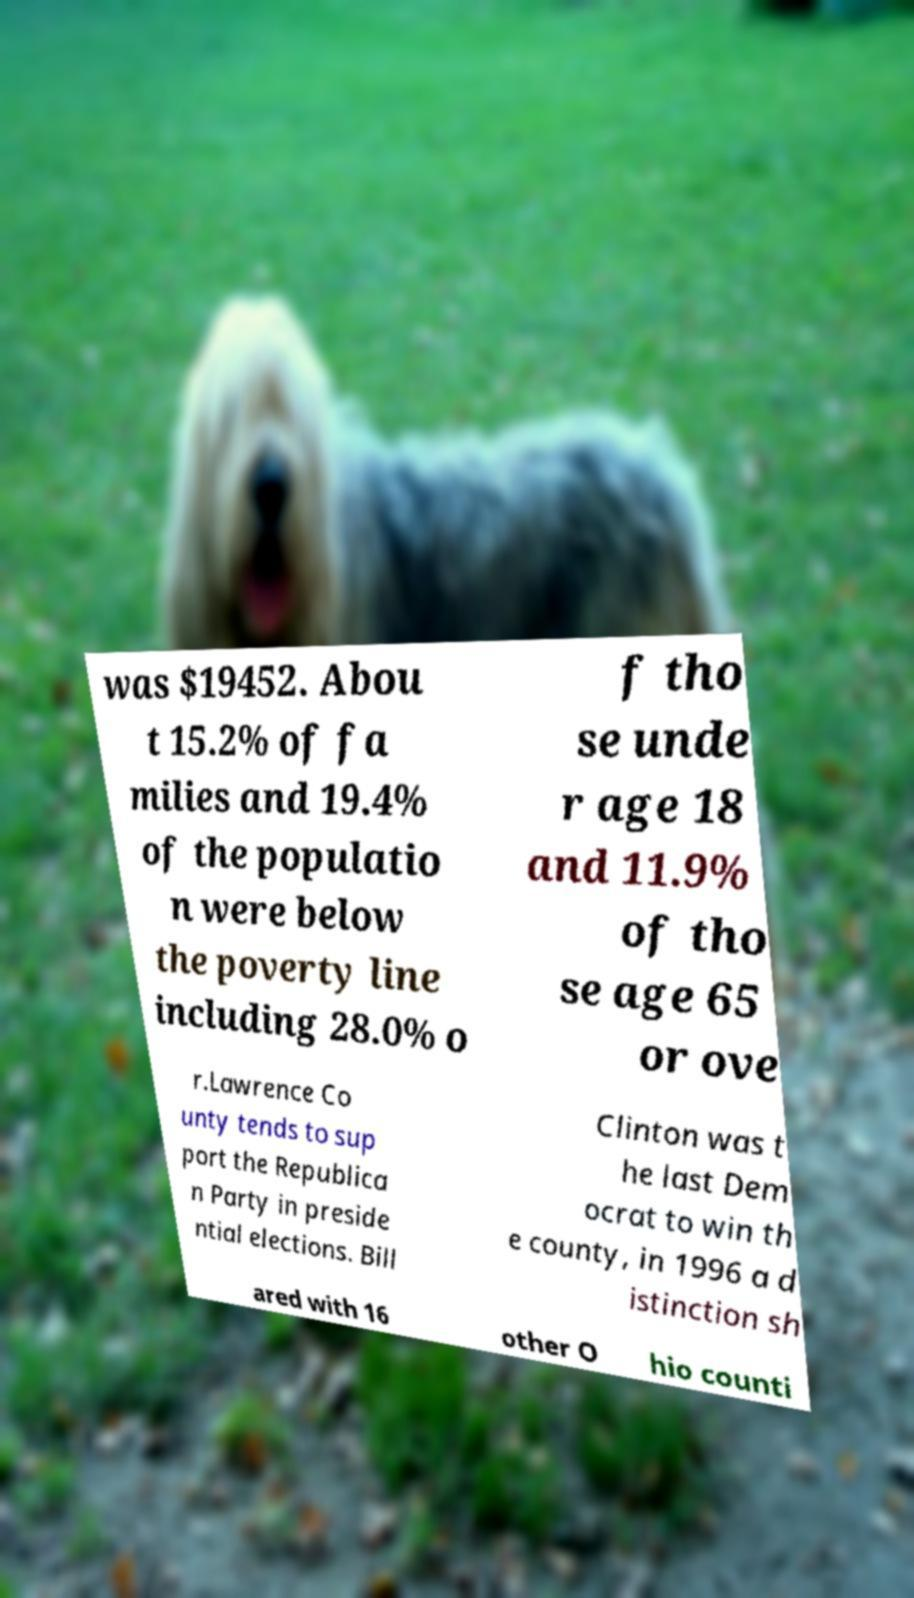What messages or text are displayed in this image? I need them in a readable, typed format. was $19452. Abou t 15.2% of fa milies and 19.4% of the populatio n were below the poverty line including 28.0% o f tho se unde r age 18 and 11.9% of tho se age 65 or ove r.Lawrence Co unty tends to sup port the Republica n Party in preside ntial elections. Bill Clinton was t he last Dem ocrat to win th e county, in 1996 a d istinction sh ared with 16 other O hio counti 